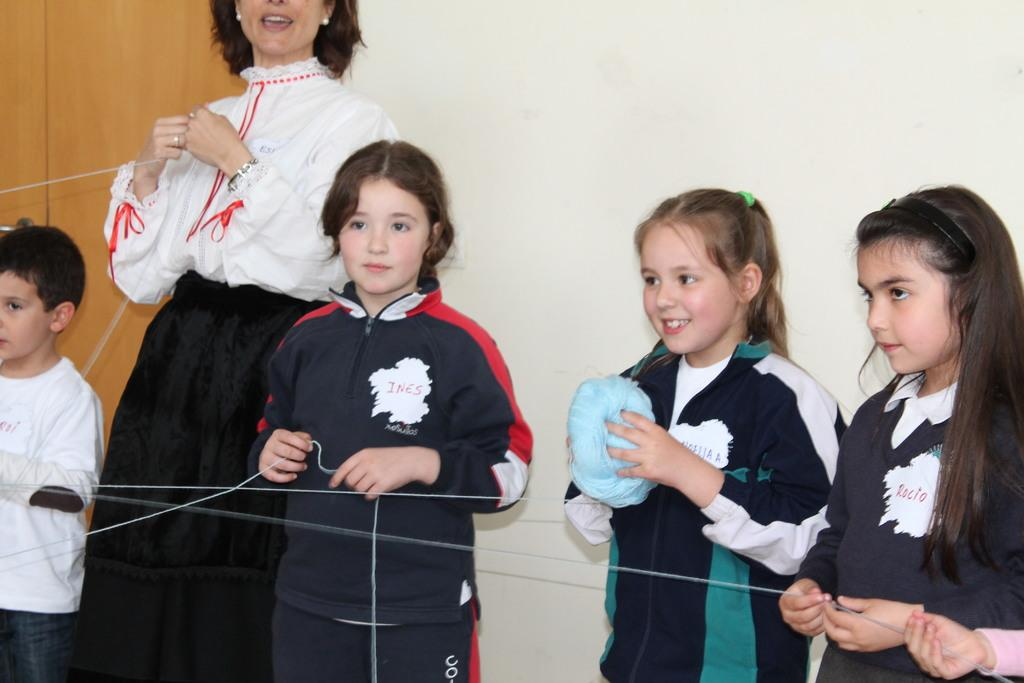Who is present in the image? There is a woman and a group of kids in the image. What are the kids holding in the image? The kids are holding a thread and one of them is holding a thread roll. What can be seen in the background of the image? There is a wall in the background of the image. What type of ear is visible on the woman in the image? There is no ear visible on the woman in the image. Can you see a rose in the hands of any of the kids? There is no rose present in the image. 